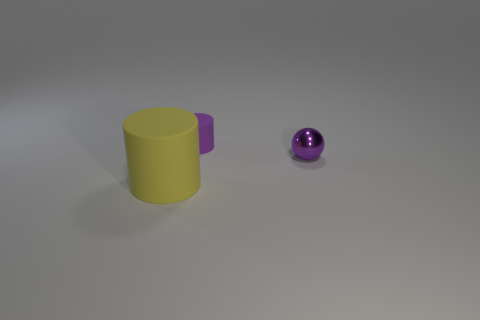Are there any other things that have the same material as the big object?
Make the answer very short. Yes. What number of rubber objects are purple balls or purple cylinders?
Your answer should be compact. 1. What material is the thing that is the same size as the metallic sphere?
Give a very brief answer. Rubber. Are there any yellow things made of the same material as the yellow cylinder?
Offer a terse response. No. There is a purple thing that is in front of the matte object that is behind the matte thing that is in front of the ball; what shape is it?
Offer a very short reply. Sphere. Do the yellow rubber thing and the purple thing behind the ball have the same size?
Give a very brief answer. No. What is the shape of the object that is on the left side of the small ball and behind the yellow rubber cylinder?
Provide a short and direct response. Cylinder. How many large objects are either spheres or purple rubber things?
Your answer should be very brief. 0. Is the number of tiny purple objects behind the tiny matte object the same as the number of tiny purple metal things in front of the yellow rubber cylinder?
Your response must be concise. Yes. What number of other objects are the same color as the small rubber cylinder?
Provide a short and direct response. 1. 